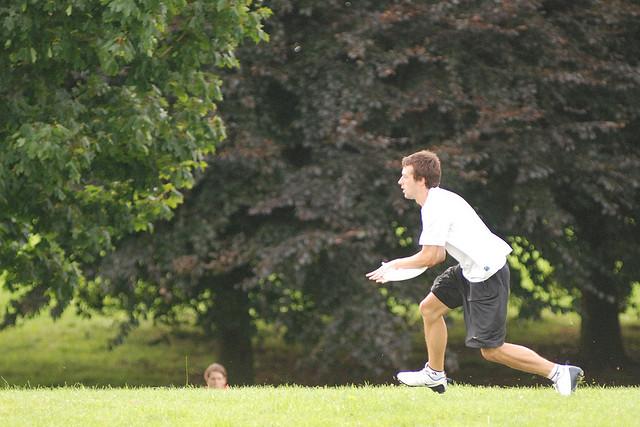Is the man in motion?
Be succinct. Yes. What is he throwing?
Write a very short answer. Frisbee. How many trees are there?
Quick response, please. 3. 